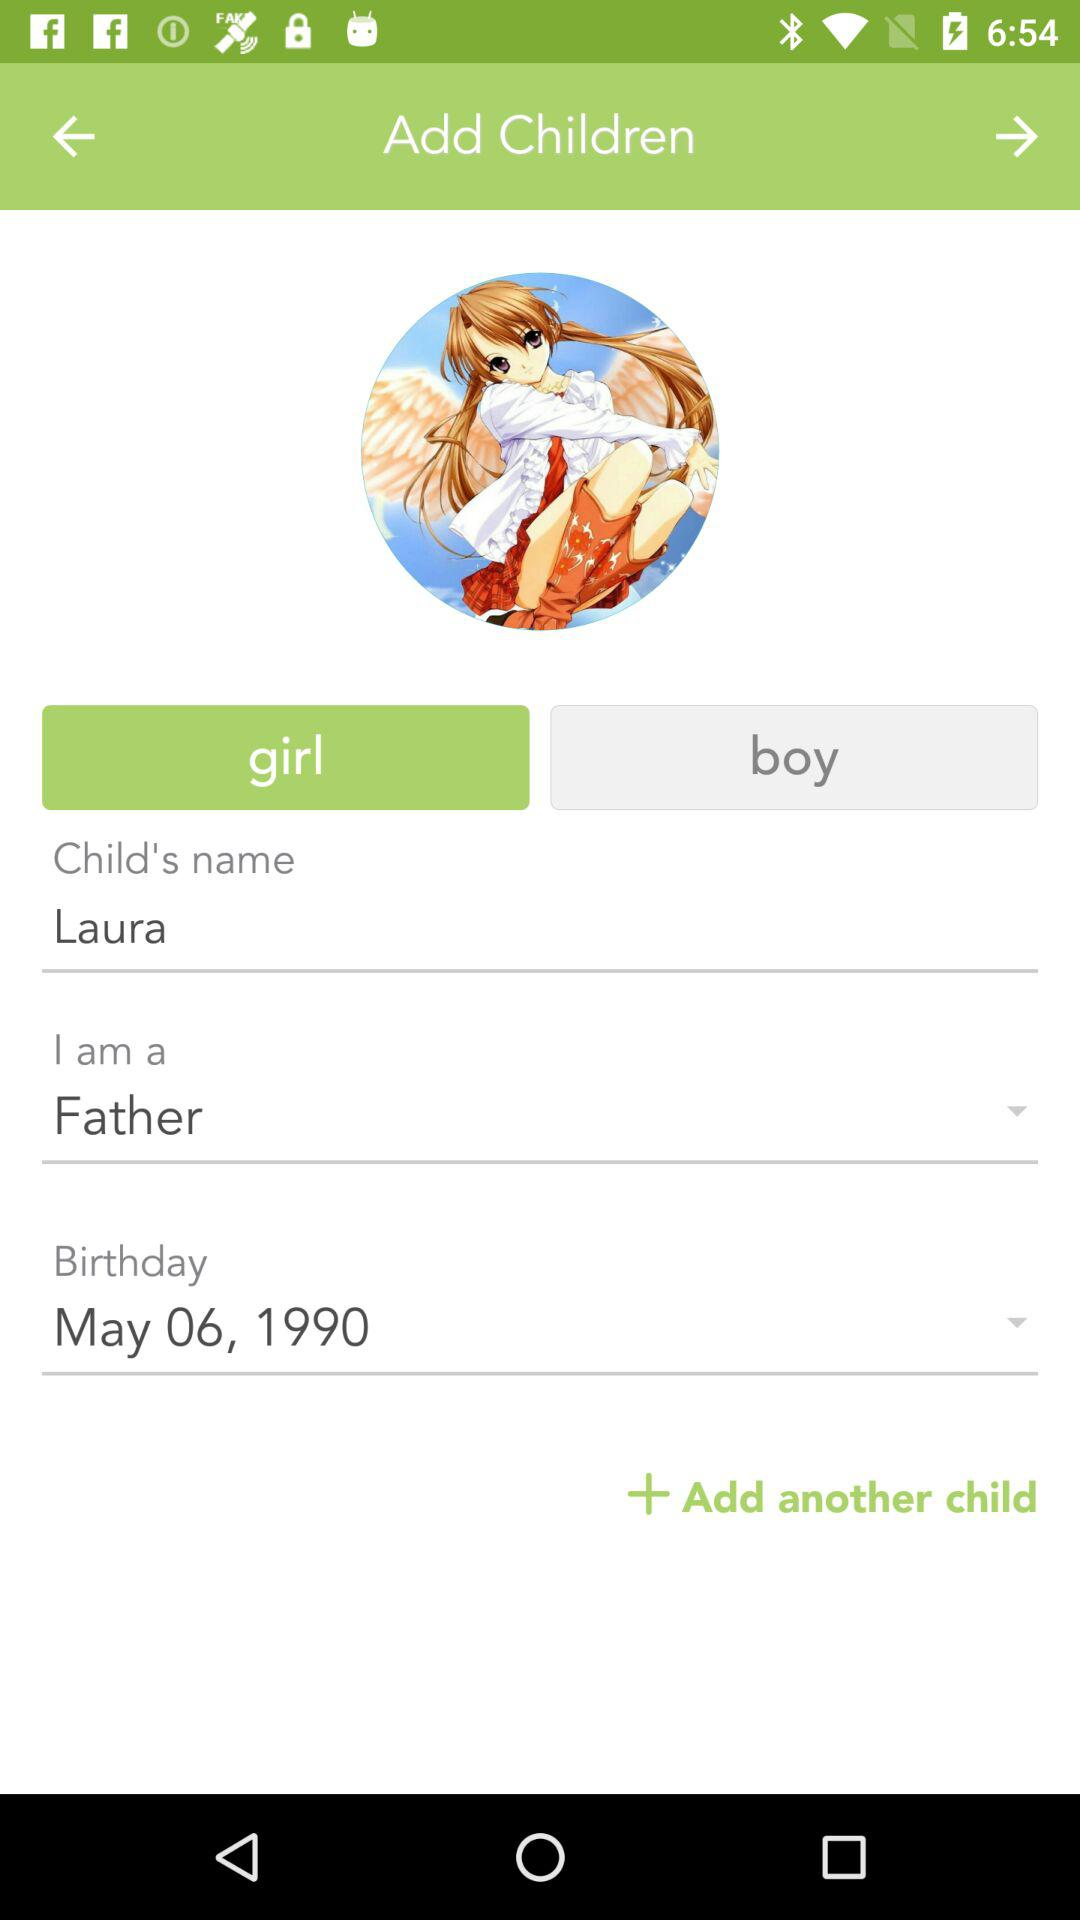What is the child's gender?
Answer the question using a single word or phrase. It's a girl. 